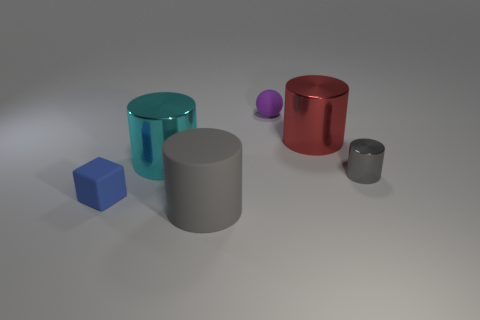What material is the other cylinder that is the same color as the tiny shiny cylinder?
Give a very brief answer. Rubber. Are there any other things that have the same shape as the large cyan thing?
Provide a succinct answer. Yes. There is a cylinder that is to the right of the big gray rubber cylinder and to the left of the tiny gray shiny cylinder; what is its color?
Provide a succinct answer. Red. There is a big metallic thing that is to the right of the large gray thing; what is its shape?
Ensure brevity in your answer.  Cylinder. There is a rubber thing on the left side of the large cylinder on the left side of the large object that is in front of the cyan shiny cylinder; what size is it?
Offer a terse response. Small. How many large matte cylinders are in front of the shiny thing in front of the cyan shiny cylinder?
Make the answer very short. 1. What is the size of the object that is behind the blue object and in front of the big cyan cylinder?
Your answer should be compact. Small. What number of metallic things are either blue blocks or cylinders?
Offer a terse response. 3. What is the material of the big gray thing?
Your answer should be very brief. Rubber. What is the material of the small thing that is behind the gray thing right of the rubber thing behind the big cyan metallic object?
Offer a very short reply. Rubber. 